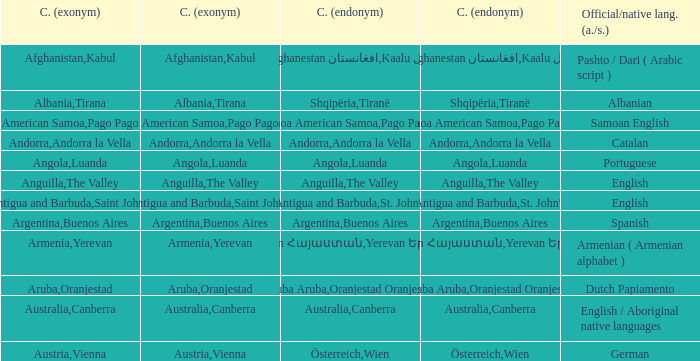What is the English name of the country whose official native language is Dutch Papiamento? Aruba. 